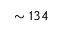<formula> <loc_0><loc_0><loc_500><loc_500>\sim 1 3 4</formula> 